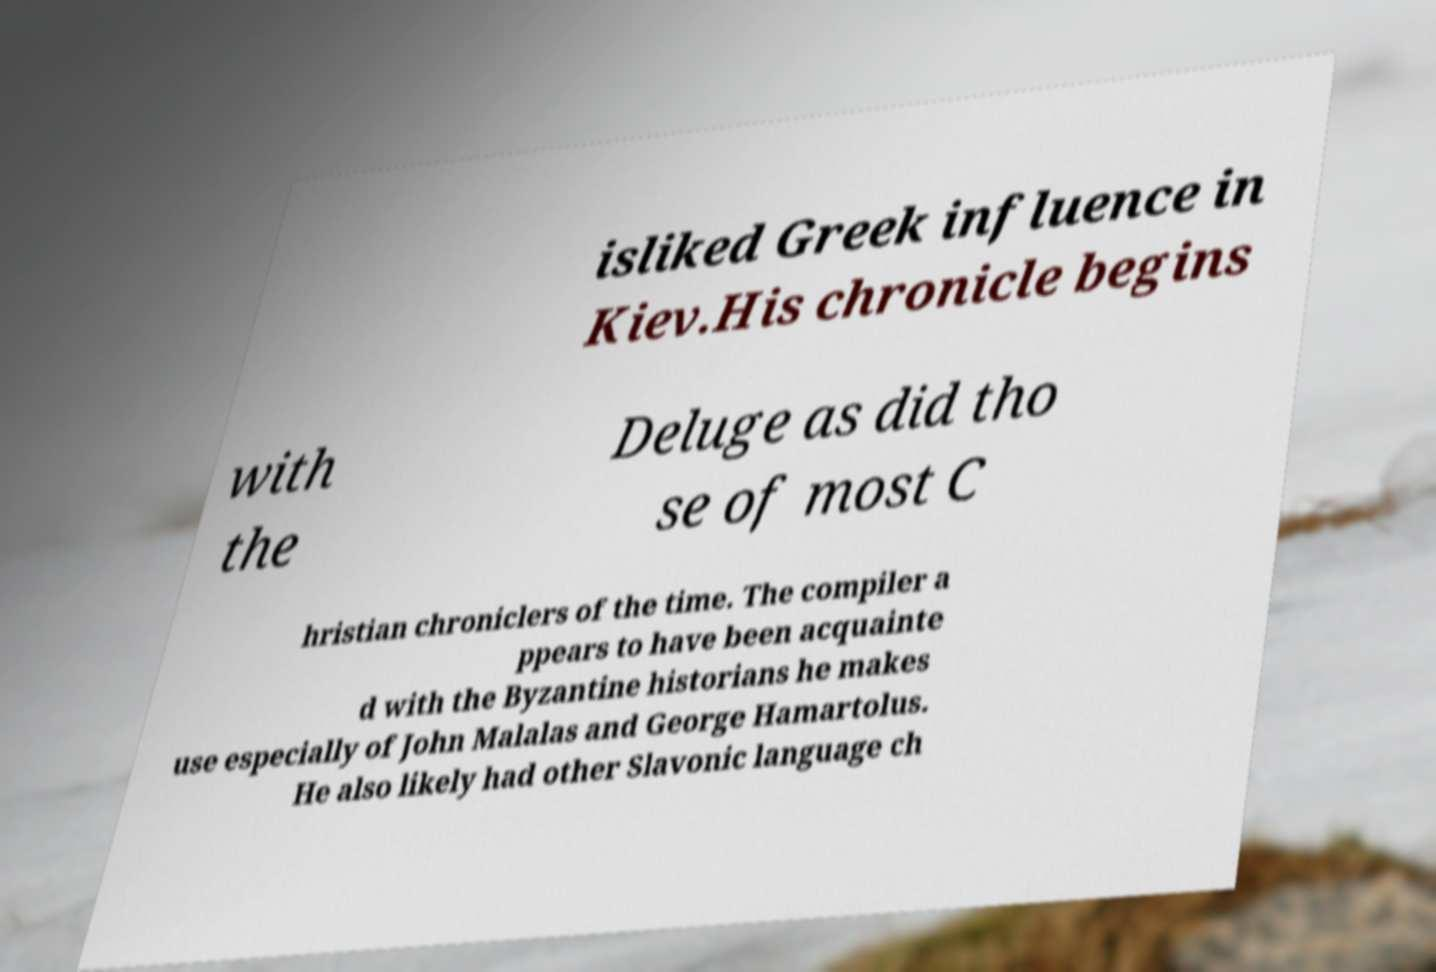Can you read and provide the text displayed in the image?This photo seems to have some interesting text. Can you extract and type it out for me? isliked Greek influence in Kiev.His chronicle begins with the Deluge as did tho se of most C hristian chroniclers of the time. The compiler a ppears to have been acquainte d with the Byzantine historians he makes use especially of John Malalas and George Hamartolus. He also likely had other Slavonic language ch 